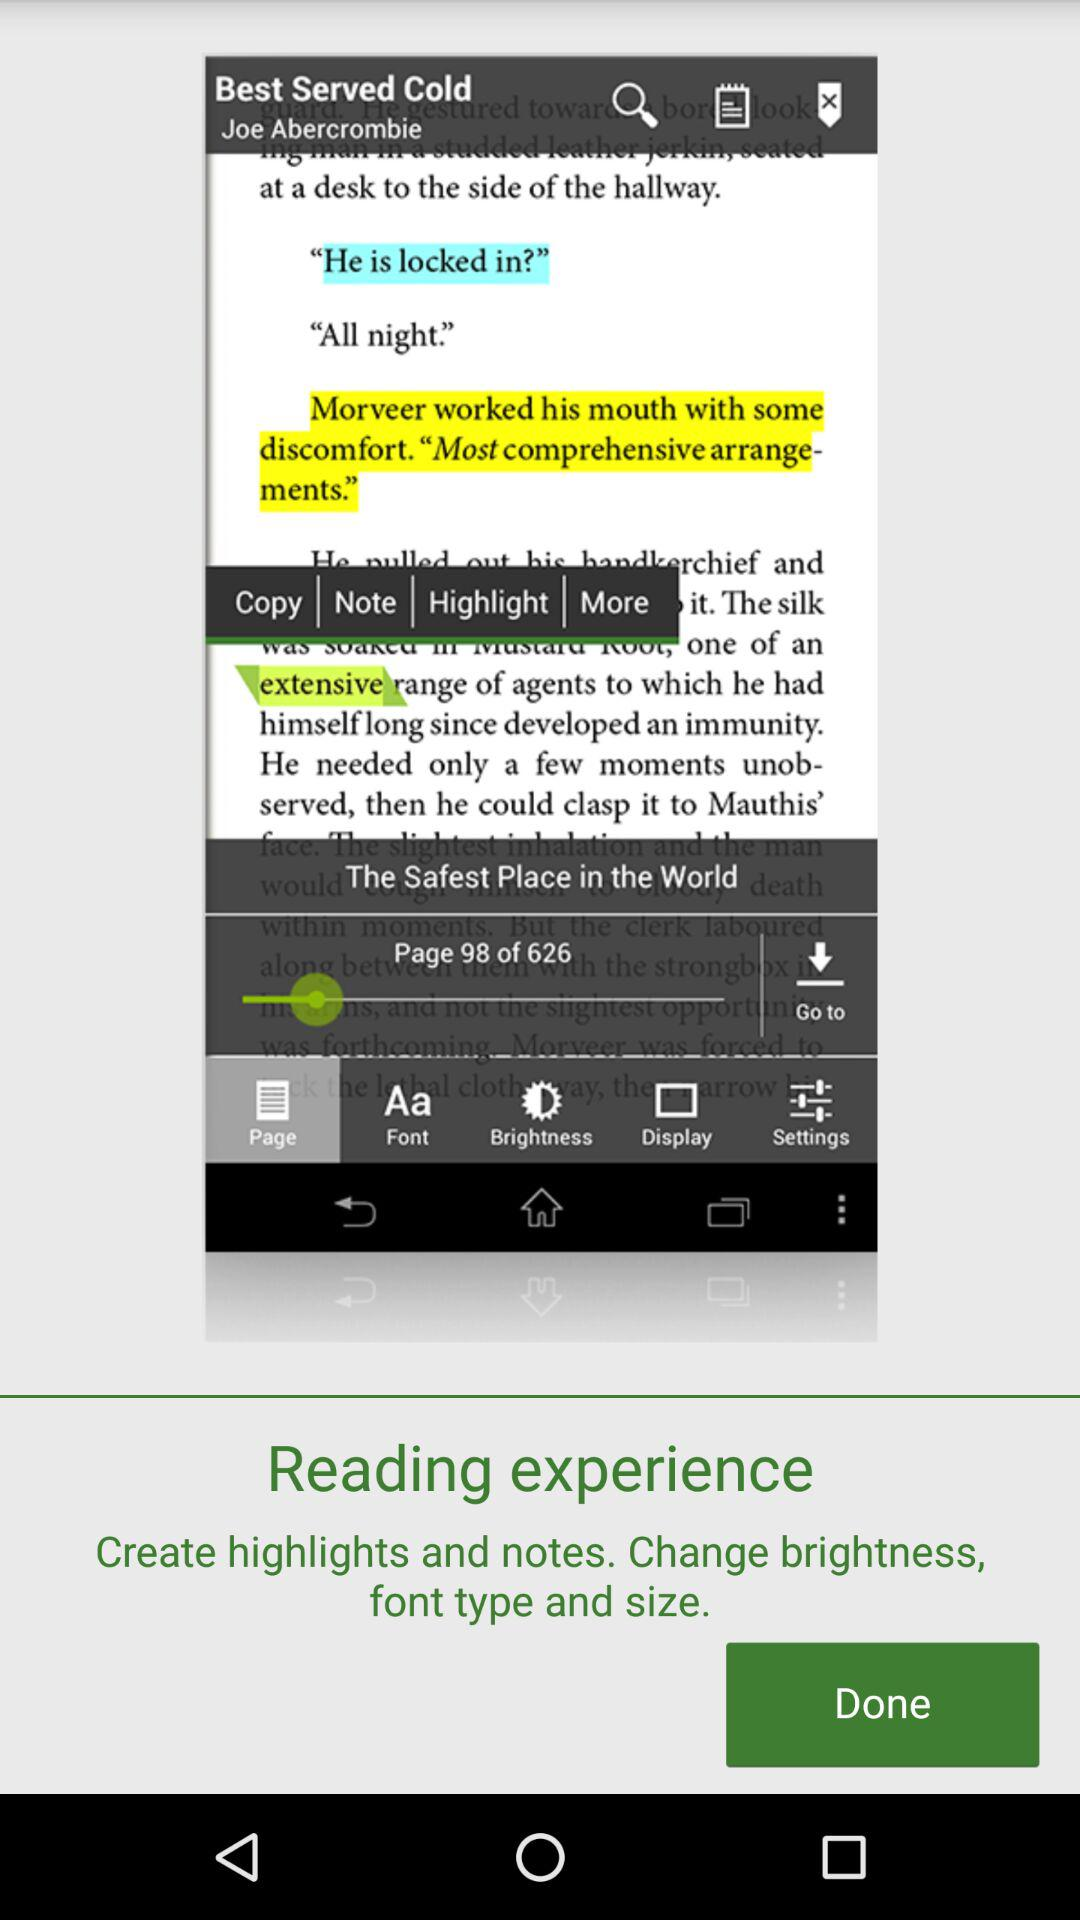Which option is selected? The selected option is "Page". 